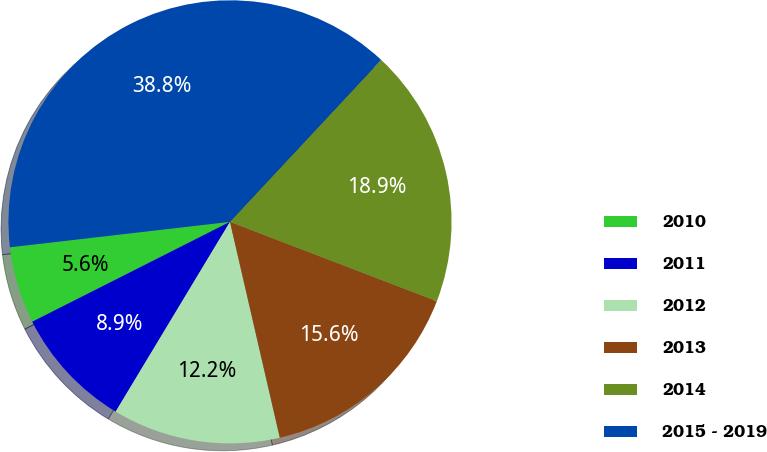Convert chart. <chart><loc_0><loc_0><loc_500><loc_500><pie_chart><fcel>2010<fcel>2011<fcel>2012<fcel>2013<fcel>2014<fcel>2015 - 2019<nl><fcel>5.61%<fcel>8.93%<fcel>12.24%<fcel>15.56%<fcel>18.88%<fcel>38.79%<nl></chart> 